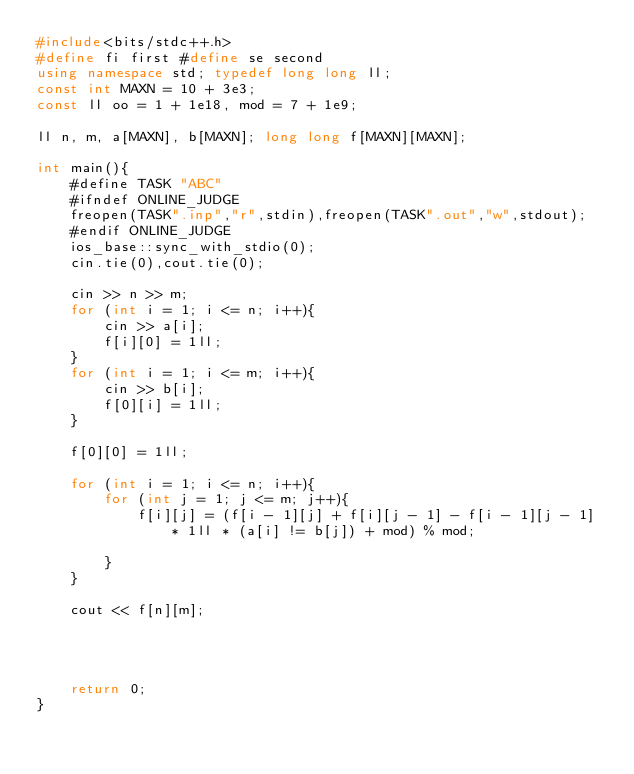Convert code to text. <code><loc_0><loc_0><loc_500><loc_500><_C++_>#include<bits/stdc++.h>
#define fi first #define se second
using namespace std; typedef long long ll;
const int MAXN = 10 + 3e3;
const ll oo = 1 + 1e18, mod = 7 + 1e9;

ll n, m, a[MAXN], b[MAXN]; long long f[MAXN][MAXN];

int main(){
    #define TASK "ABC"
    #ifndef ONLINE_JUDGE
    freopen(TASK".inp","r",stdin),freopen(TASK".out","w",stdout);
    #endif ONLINE_JUDGE
    ios_base::sync_with_stdio(0);
    cin.tie(0),cout.tie(0);

    cin >> n >> m;
    for (int i = 1; i <= n; i++){
        cin >> a[i];
        f[i][0] = 1ll;
    }
    for (int i = 1; i <= m; i++){
        cin >> b[i];
        f[0][i] = 1ll;
    }

    f[0][0] = 1ll;

    for (int i = 1; i <= n; i++){
        for (int j = 1; j <= m; j++){
            f[i][j] = (f[i - 1][j] + f[i][j - 1] - f[i - 1][j - 1] * 1ll * (a[i] != b[j]) + mod) % mod;

        }
    }

    cout << f[n][m];




    return 0;
}
</code> 